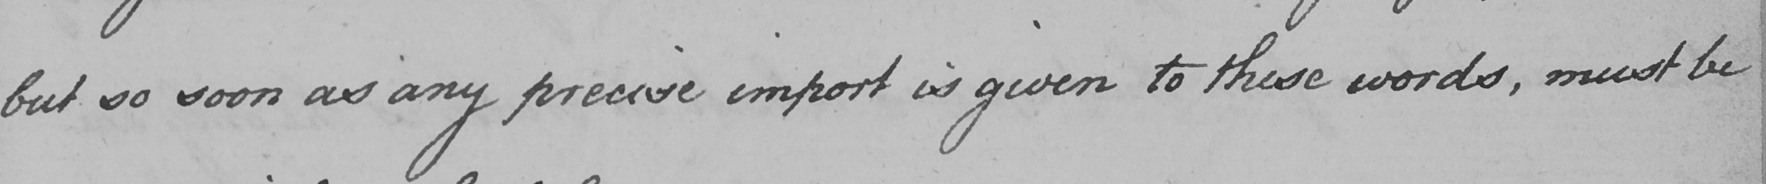Please transcribe the handwritten text in this image. but so soon as any precise import is given to these words , must be 